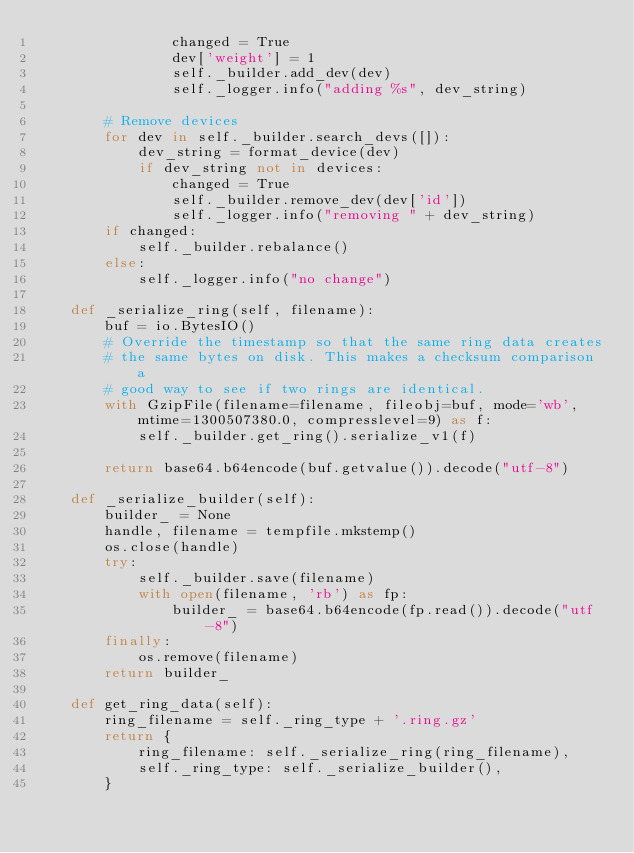Convert code to text. <code><loc_0><loc_0><loc_500><loc_500><_Python_>                changed = True
                dev['weight'] = 1
                self._builder.add_dev(dev)
                self._logger.info("adding %s", dev_string)

        # Remove devices
        for dev in self._builder.search_devs([]):
            dev_string = format_device(dev)
            if dev_string not in devices:
                changed = True
                self._builder.remove_dev(dev['id'])
                self._logger.info("removing " + dev_string)
        if changed:
            self._builder.rebalance()
        else:
            self._logger.info("no change")

    def _serialize_ring(self, filename):
        buf = io.BytesIO()
        # Override the timestamp so that the same ring data creates
        # the same bytes on disk. This makes a checksum comparison a
        # good way to see if two rings are identical.
        with GzipFile(filename=filename, fileobj=buf, mode='wb', mtime=1300507380.0, compresslevel=9) as f:
            self._builder.get_ring().serialize_v1(f)

        return base64.b64encode(buf.getvalue()).decode("utf-8")

    def _serialize_builder(self):
        builder_ = None
        handle, filename = tempfile.mkstemp()
        os.close(handle)
        try:
            self._builder.save(filename)
            with open(filename, 'rb') as fp:
                builder_ = base64.b64encode(fp.read()).decode("utf-8")
        finally:
            os.remove(filename)
        return builder_

    def get_ring_data(self):
        ring_filename = self._ring_type + '.ring.gz'
        return {
            ring_filename: self._serialize_ring(ring_filename),
            self._ring_type: self._serialize_builder(),
        }
</code> 